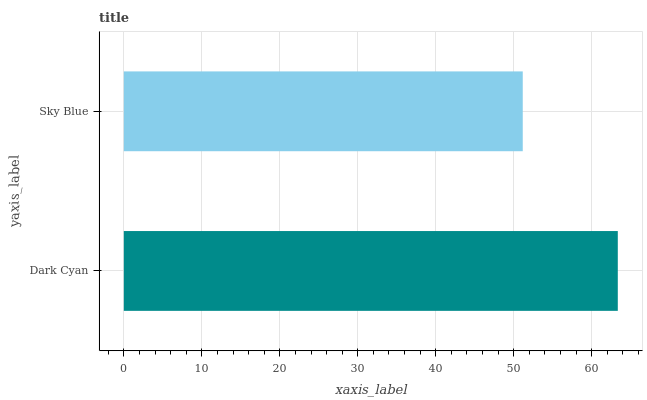Is Sky Blue the minimum?
Answer yes or no. Yes. Is Dark Cyan the maximum?
Answer yes or no. Yes. Is Sky Blue the maximum?
Answer yes or no. No. Is Dark Cyan greater than Sky Blue?
Answer yes or no. Yes. Is Sky Blue less than Dark Cyan?
Answer yes or no. Yes. Is Sky Blue greater than Dark Cyan?
Answer yes or no. No. Is Dark Cyan less than Sky Blue?
Answer yes or no. No. Is Dark Cyan the high median?
Answer yes or no. Yes. Is Sky Blue the low median?
Answer yes or no. Yes. Is Sky Blue the high median?
Answer yes or no. No. Is Dark Cyan the low median?
Answer yes or no. No. 